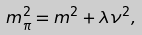<formula> <loc_0><loc_0><loc_500><loc_500>m _ { \pi } ^ { 2 } = m ^ { 2 } + \lambda \nu ^ { 2 } ,</formula> 